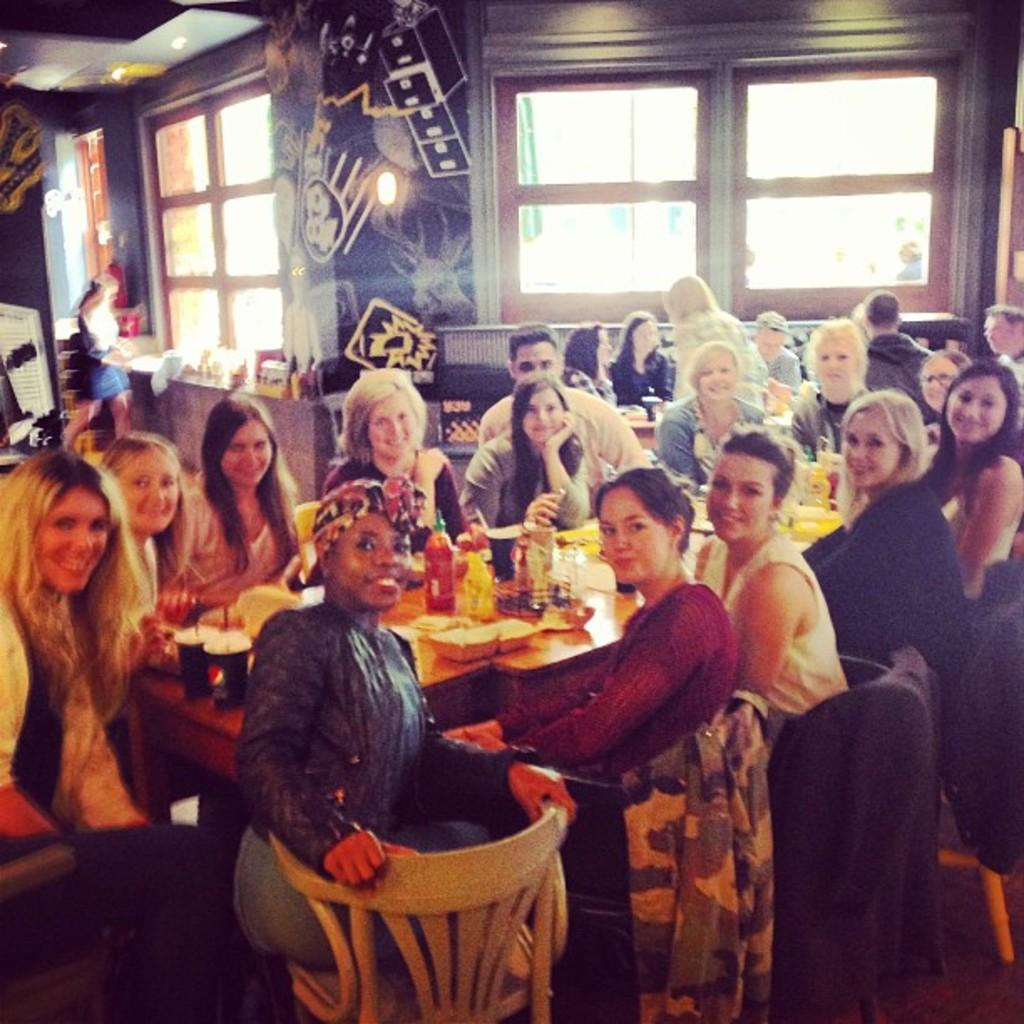How many people are in the image? There is a group of people in the image. What are the people doing in the image? The people are sitting in front of a table. What is the facial expression of the people in the image? The people are smiling. What can be seen in the background of the image? There is a window visible in the background of the image. How many mice are crawling on the table in the image? There are no mice present in the image. What type of bubble is floating near the window in the image? There is no bubble present in the image. 